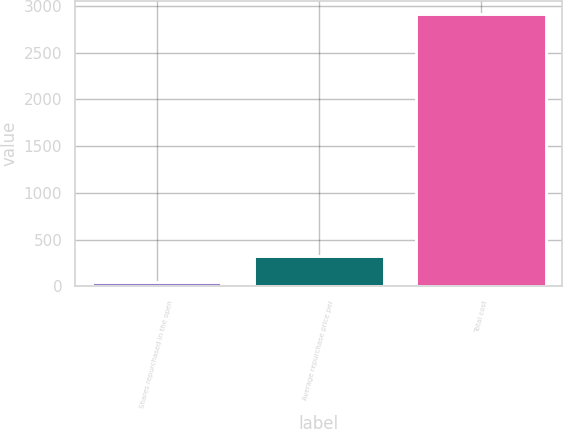Convert chart. <chart><loc_0><loc_0><loc_500><loc_500><bar_chart><fcel>Shares repurchased in the open<fcel>Average repurchase price per<fcel>Total cost<nl><fcel>44<fcel>330.6<fcel>2910<nl></chart> 